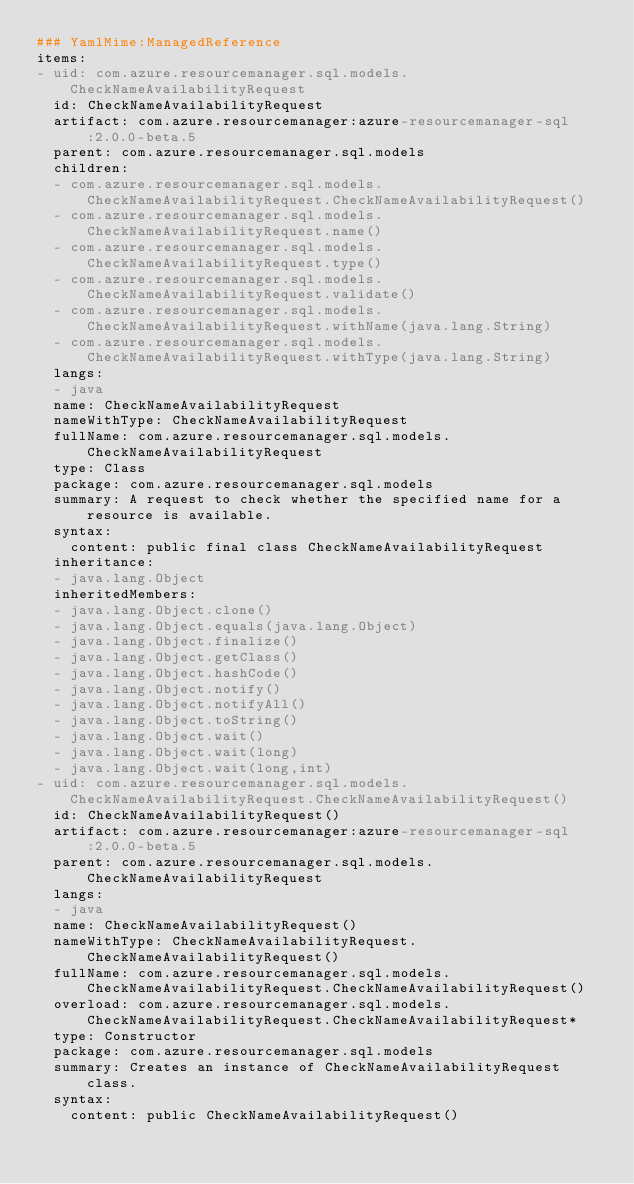<code> <loc_0><loc_0><loc_500><loc_500><_YAML_>### YamlMime:ManagedReference
items:
- uid: com.azure.resourcemanager.sql.models.CheckNameAvailabilityRequest
  id: CheckNameAvailabilityRequest
  artifact: com.azure.resourcemanager:azure-resourcemanager-sql:2.0.0-beta.5
  parent: com.azure.resourcemanager.sql.models
  children:
  - com.azure.resourcemanager.sql.models.CheckNameAvailabilityRequest.CheckNameAvailabilityRequest()
  - com.azure.resourcemanager.sql.models.CheckNameAvailabilityRequest.name()
  - com.azure.resourcemanager.sql.models.CheckNameAvailabilityRequest.type()
  - com.azure.resourcemanager.sql.models.CheckNameAvailabilityRequest.validate()
  - com.azure.resourcemanager.sql.models.CheckNameAvailabilityRequest.withName(java.lang.String)
  - com.azure.resourcemanager.sql.models.CheckNameAvailabilityRequest.withType(java.lang.String)
  langs:
  - java
  name: CheckNameAvailabilityRequest
  nameWithType: CheckNameAvailabilityRequest
  fullName: com.azure.resourcemanager.sql.models.CheckNameAvailabilityRequest
  type: Class
  package: com.azure.resourcemanager.sql.models
  summary: A request to check whether the specified name for a resource is available.
  syntax:
    content: public final class CheckNameAvailabilityRequest
  inheritance:
  - java.lang.Object
  inheritedMembers:
  - java.lang.Object.clone()
  - java.lang.Object.equals(java.lang.Object)
  - java.lang.Object.finalize()
  - java.lang.Object.getClass()
  - java.lang.Object.hashCode()
  - java.lang.Object.notify()
  - java.lang.Object.notifyAll()
  - java.lang.Object.toString()
  - java.lang.Object.wait()
  - java.lang.Object.wait(long)
  - java.lang.Object.wait(long,int)
- uid: com.azure.resourcemanager.sql.models.CheckNameAvailabilityRequest.CheckNameAvailabilityRequest()
  id: CheckNameAvailabilityRequest()
  artifact: com.azure.resourcemanager:azure-resourcemanager-sql:2.0.0-beta.5
  parent: com.azure.resourcemanager.sql.models.CheckNameAvailabilityRequest
  langs:
  - java
  name: CheckNameAvailabilityRequest()
  nameWithType: CheckNameAvailabilityRequest.CheckNameAvailabilityRequest()
  fullName: com.azure.resourcemanager.sql.models.CheckNameAvailabilityRequest.CheckNameAvailabilityRequest()
  overload: com.azure.resourcemanager.sql.models.CheckNameAvailabilityRequest.CheckNameAvailabilityRequest*
  type: Constructor
  package: com.azure.resourcemanager.sql.models
  summary: Creates an instance of CheckNameAvailabilityRequest class.
  syntax:
    content: public CheckNameAvailabilityRequest()</code> 